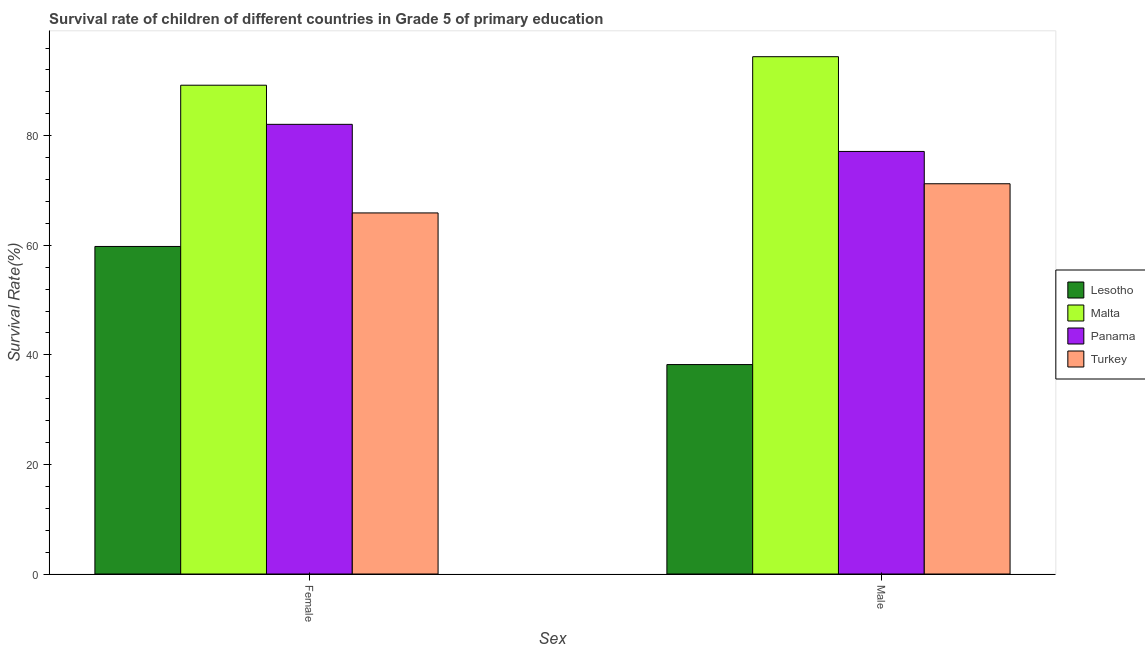How many groups of bars are there?
Make the answer very short. 2. How many bars are there on the 2nd tick from the left?
Provide a short and direct response. 4. How many bars are there on the 2nd tick from the right?
Keep it short and to the point. 4. What is the survival rate of male students in primary education in Malta?
Your answer should be very brief. 94.43. Across all countries, what is the maximum survival rate of male students in primary education?
Offer a very short reply. 94.43. Across all countries, what is the minimum survival rate of female students in primary education?
Your answer should be very brief. 59.79. In which country was the survival rate of male students in primary education maximum?
Your answer should be very brief. Malta. In which country was the survival rate of male students in primary education minimum?
Give a very brief answer. Lesotho. What is the total survival rate of female students in primary education in the graph?
Your response must be concise. 296.99. What is the difference between the survival rate of female students in primary education in Lesotho and that in Turkey?
Give a very brief answer. -6.12. What is the difference between the survival rate of male students in primary education in Malta and the survival rate of female students in primary education in Panama?
Your answer should be compact. 12.35. What is the average survival rate of male students in primary education per country?
Offer a terse response. 70.25. What is the difference between the survival rate of female students in primary education and survival rate of male students in primary education in Turkey?
Offer a terse response. -5.32. In how many countries, is the survival rate of female students in primary education greater than 60 %?
Provide a short and direct response. 3. What is the ratio of the survival rate of female students in primary education in Lesotho to that in Turkey?
Give a very brief answer. 0.91. What does the 3rd bar from the left in Male represents?
Provide a short and direct response. Panama. How many bars are there?
Provide a short and direct response. 8. Are all the bars in the graph horizontal?
Make the answer very short. No. What is the difference between two consecutive major ticks on the Y-axis?
Make the answer very short. 20. Are the values on the major ticks of Y-axis written in scientific E-notation?
Give a very brief answer. No. Does the graph contain grids?
Your response must be concise. No. How are the legend labels stacked?
Your answer should be very brief. Vertical. What is the title of the graph?
Keep it short and to the point. Survival rate of children of different countries in Grade 5 of primary education. What is the label or title of the X-axis?
Your response must be concise. Sex. What is the label or title of the Y-axis?
Ensure brevity in your answer.  Survival Rate(%). What is the Survival Rate(%) in Lesotho in Female?
Your answer should be very brief. 59.79. What is the Survival Rate(%) of Malta in Female?
Your response must be concise. 89.22. What is the Survival Rate(%) of Panama in Female?
Your answer should be compact. 82.08. What is the Survival Rate(%) in Turkey in Female?
Offer a very short reply. 65.91. What is the Survival Rate(%) of Lesotho in Male?
Provide a succinct answer. 38.23. What is the Survival Rate(%) in Malta in Male?
Keep it short and to the point. 94.43. What is the Survival Rate(%) of Panama in Male?
Your response must be concise. 77.13. What is the Survival Rate(%) of Turkey in Male?
Keep it short and to the point. 71.23. Across all Sex, what is the maximum Survival Rate(%) of Lesotho?
Offer a terse response. 59.79. Across all Sex, what is the maximum Survival Rate(%) of Malta?
Give a very brief answer. 94.43. Across all Sex, what is the maximum Survival Rate(%) in Panama?
Give a very brief answer. 82.08. Across all Sex, what is the maximum Survival Rate(%) in Turkey?
Your answer should be very brief. 71.23. Across all Sex, what is the minimum Survival Rate(%) in Lesotho?
Make the answer very short. 38.23. Across all Sex, what is the minimum Survival Rate(%) of Malta?
Your answer should be compact. 89.22. Across all Sex, what is the minimum Survival Rate(%) of Panama?
Give a very brief answer. 77.13. Across all Sex, what is the minimum Survival Rate(%) of Turkey?
Offer a very short reply. 65.91. What is the total Survival Rate(%) of Lesotho in the graph?
Provide a short and direct response. 98.01. What is the total Survival Rate(%) in Malta in the graph?
Give a very brief answer. 183.65. What is the total Survival Rate(%) in Panama in the graph?
Offer a very short reply. 159.21. What is the total Survival Rate(%) in Turkey in the graph?
Keep it short and to the point. 137.14. What is the difference between the Survival Rate(%) in Lesotho in Female and that in Male?
Keep it short and to the point. 21.56. What is the difference between the Survival Rate(%) of Malta in Female and that in Male?
Your answer should be compact. -5.21. What is the difference between the Survival Rate(%) of Panama in Female and that in Male?
Ensure brevity in your answer.  4.95. What is the difference between the Survival Rate(%) of Turkey in Female and that in Male?
Your answer should be very brief. -5.32. What is the difference between the Survival Rate(%) of Lesotho in Female and the Survival Rate(%) of Malta in Male?
Give a very brief answer. -34.64. What is the difference between the Survival Rate(%) in Lesotho in Female and the Survival Rate(%) in Panama in Male?
Provide a succinct answer. -17.34. What is the difference between the Survival Rate(%) in Lesotho in Female and the Survival Rate(%) in Turkey in Male?
Offer a very short reply. -11.45. What is the difference between the Survival Rate(%) of Malta in Female and the Survival Rate(%) of Panama in Male?
Offer a very short reply. 12.09. What is the difference between the Survival Rate(%) in Malta in Female and the Survival Rate(%) in Turkey in Male?
Offer a very short reply. 17.99. What is the difference between the Survival Rate(%) of Panama in Female and the Survival Rate(%) of Turkey in Male?
Provide a succinct answer. 10.85. What is the average Survival Rate(%) in Lesotho per Sex?
Ensure brevity in your answer.  49.01. What is the average Survival Rate(%) of Malta per Sex?
Your answer should be very brief. 91.82. What is the average Survival Rate(%) of Panama per Sex?
Keep it short and to the point. 79.6. What is the average Survival Rate(%) of Turkey per Sex?
Offer a very short reply. 68.57. What is the difference between the Survival Rate(%) of Lesotho and Survival Rate(%) of Malta in Female?
Ensure brevity in your answer.  -29.43. What is the difference between the Survival Rate(%) of Lesotho and Survival Rate(%) of Panama in Female?
Offer a terse response. -22.29. What is the difference between the Survival Rate(%) in Lesotho and Survival Rate(%) in Turkey in Female?
Offer a very short reply. -6.12. What is the difference between the Survival Rate(%) in Malta and Survival Rate(%) in Panama in Female?
Your answer should be very brief. 7.14. What is the difference between the Survival Rate(%) of Malta and Survival Rate(%) of Turkey in Female?
Your answer should be very brief. 23.31. What is the difference between the Survival Rate(%) of Panama and Survival Rate(%) of Turkey in Female?
Offer a very short reply. 16.17. What is the difference between the Survival Rate(%) of Lesotho and Survival Rate(%) of Malta in Male?
Provide a succinct answer. -56.2. What is the difference between the Survival Rate(%) in Lesotho and Survival Rate(%) in Panama in Male?
Keep it short and to the point. -38.9. What is the difference between the Survival Rate(%) in Lesotho and Survival Rate(%) in Turkey in Male?
Your response must be concise. -33. What is the difference between the Survival Rate(%) in Malta and Survival Rate(%) in Panama in Male?
Your response must be concise. 17.3. What is the difference between the Survival Rate(%) in Malta and Survival Rate(%) in Turkey in Male?
Give a very brief answer. 23.19. What is the difference between the Survival Rate(%) in Panama and Survival Rate(%) in Turkey in Male?
Offer a terse response. 5.9. What is the ratio of the Survival Rate(%) in Lesotho in Female to that in Male?
Keep it short and to the point. 1.56. What is the ratio of the Survival Rate(%) in Malta in Female to that in Male?
Offer a terse response. 0.94. What is the ratio of the Survival Rate(%) of Panama in Female to that in Male?
Your answer should be very brief. 1.06. What is the ratio of the Survival Rate(%) of Turkey in Female to that in Male?
Give a very brief answer. 0.93. What is the difference between the highest and the second highest Survival Rate(%) in Lesotho?
Offer a terse response. 21.56. What is the difference between the highest and the second highest Survival Rate(%) of Malta?
Give a very brief answer. 5.21. What is the difference between the highest and the second highest Survival Rate(%) of Panama?
Provide a succinct answer. 4.95. What is the difference between the highest and the second highest Survival Rate(%) in Turkey?
Ensure brevity in your answer.  5.32. What is the difference between the highest and the lowest Survival Rate(%) of Lesotho?
Your answer should be very brief. 21.56. What is the difference between the highest and the lowest Survival Rate(%) in Malta?
Keep it short and to the point. 5.21. What is the difference between the highest and the lowest Survival Rate(%) in Panama?
Keep it short and to the point. 4.95. What is the difference between the highest and the lowest Survival Rate(%) in Turkey?
Make the answer very short. 5.32. 